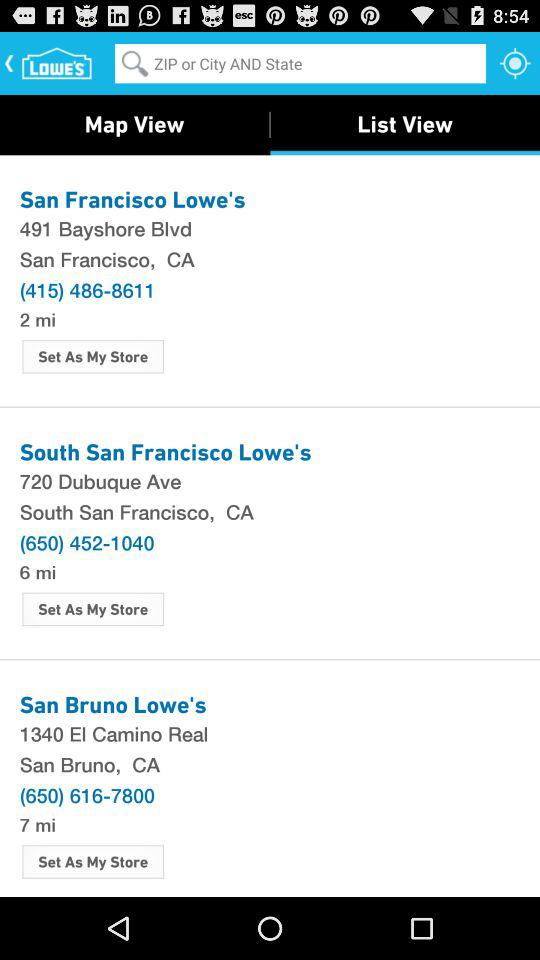What is the phone number for the South San Francisco Lowe's? The phone number is (650) 452-1040. 